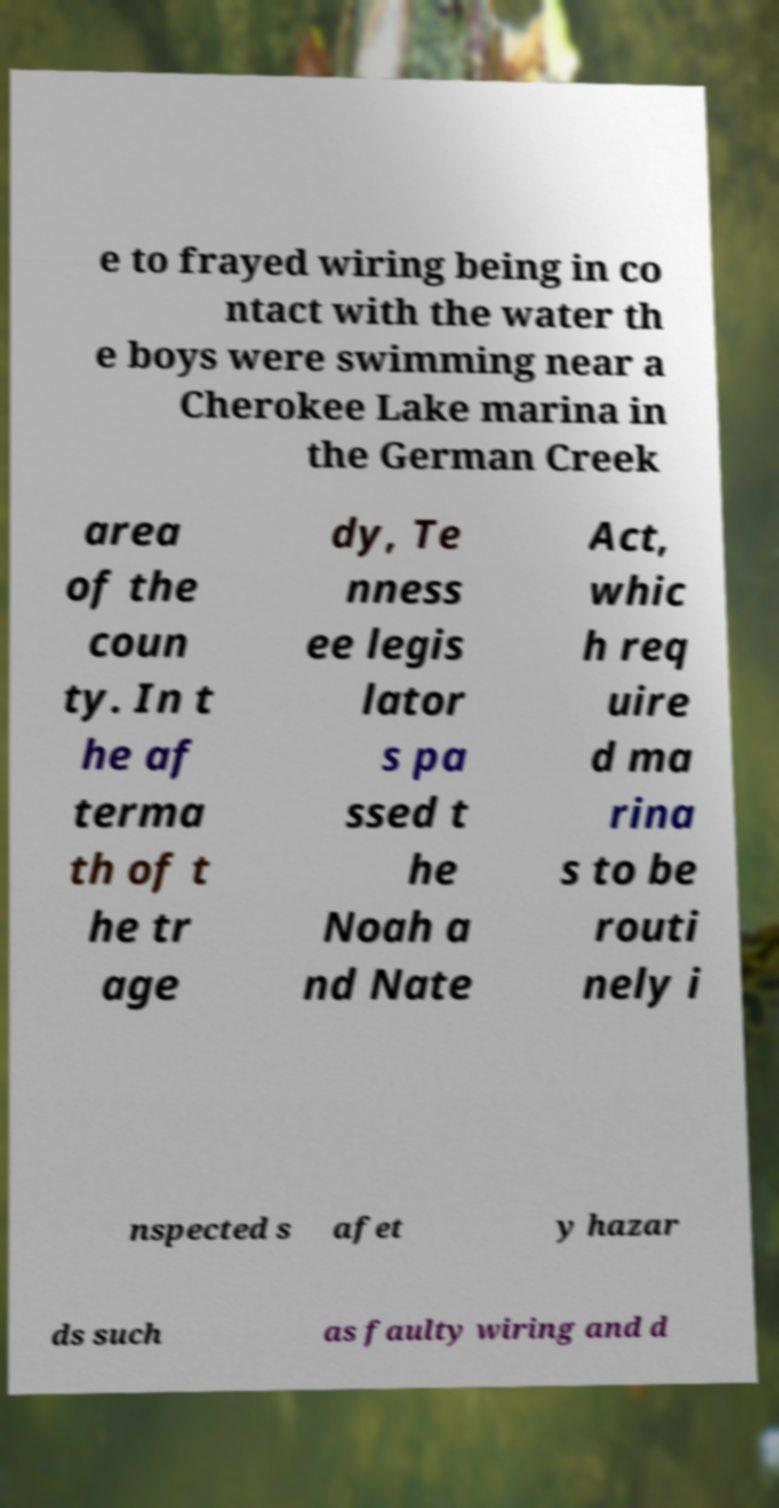For documentation purposes, I need the text within this image transcribed. Could you provide that? e to frayed wiring being in co ntact with the water th e boys were swimming near a Cherokee Lake marina in the German Creek area of the coun ty. In t he af terma th of t he tr age dy, Te nness ee legis lator s pa ssed t he Noah a nd Nate Act, whic h req uire d ma rina s to be routi nely i nspected s afet y hazar ds such as faulty wiring and d 